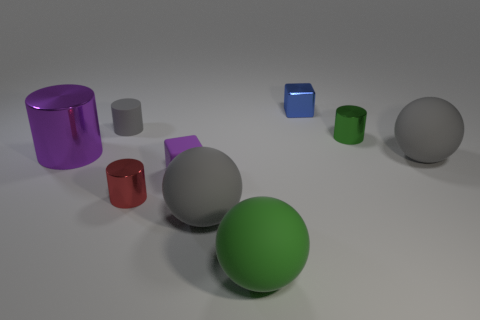What might be the purpose of this collection of objects in the image? It looks like a staged 3D rendering or a photograph of geometric shapes commonly used for graphic design, art composition practice, or to test rendering settings such as lighting and shadow in a virtual environment. 